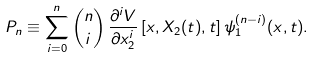Convert formula to latex. <formula><loc_0><loc_0><loc_500><loc_500>P _ { n } \equiv \sum _ { i = 0 } ^ { n } \binom { n } { i } \, \frac { \partial ^ { i } V } { \partial x _ { 2 } ^ { i } } \left [ x , X _ { 2 } ( t ) , t \right ] \psi ^ { ( n - i ) } _ { 1 } ( x , t ) .</formula> 